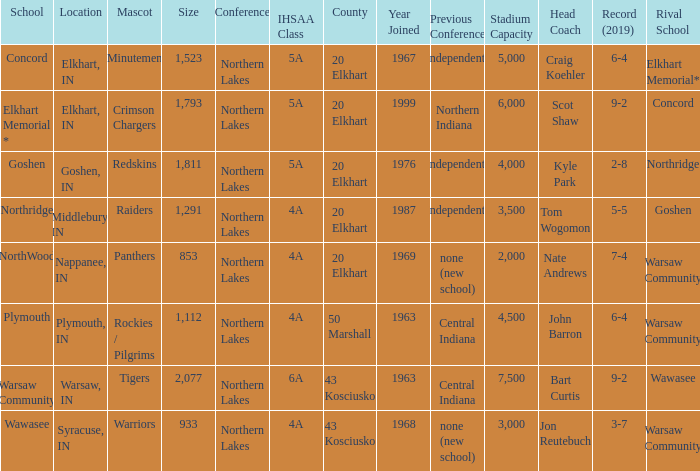What is the size of the team that was previously from Central Indiana conference, and is in IHSSA Class 4a? 1112.0. 